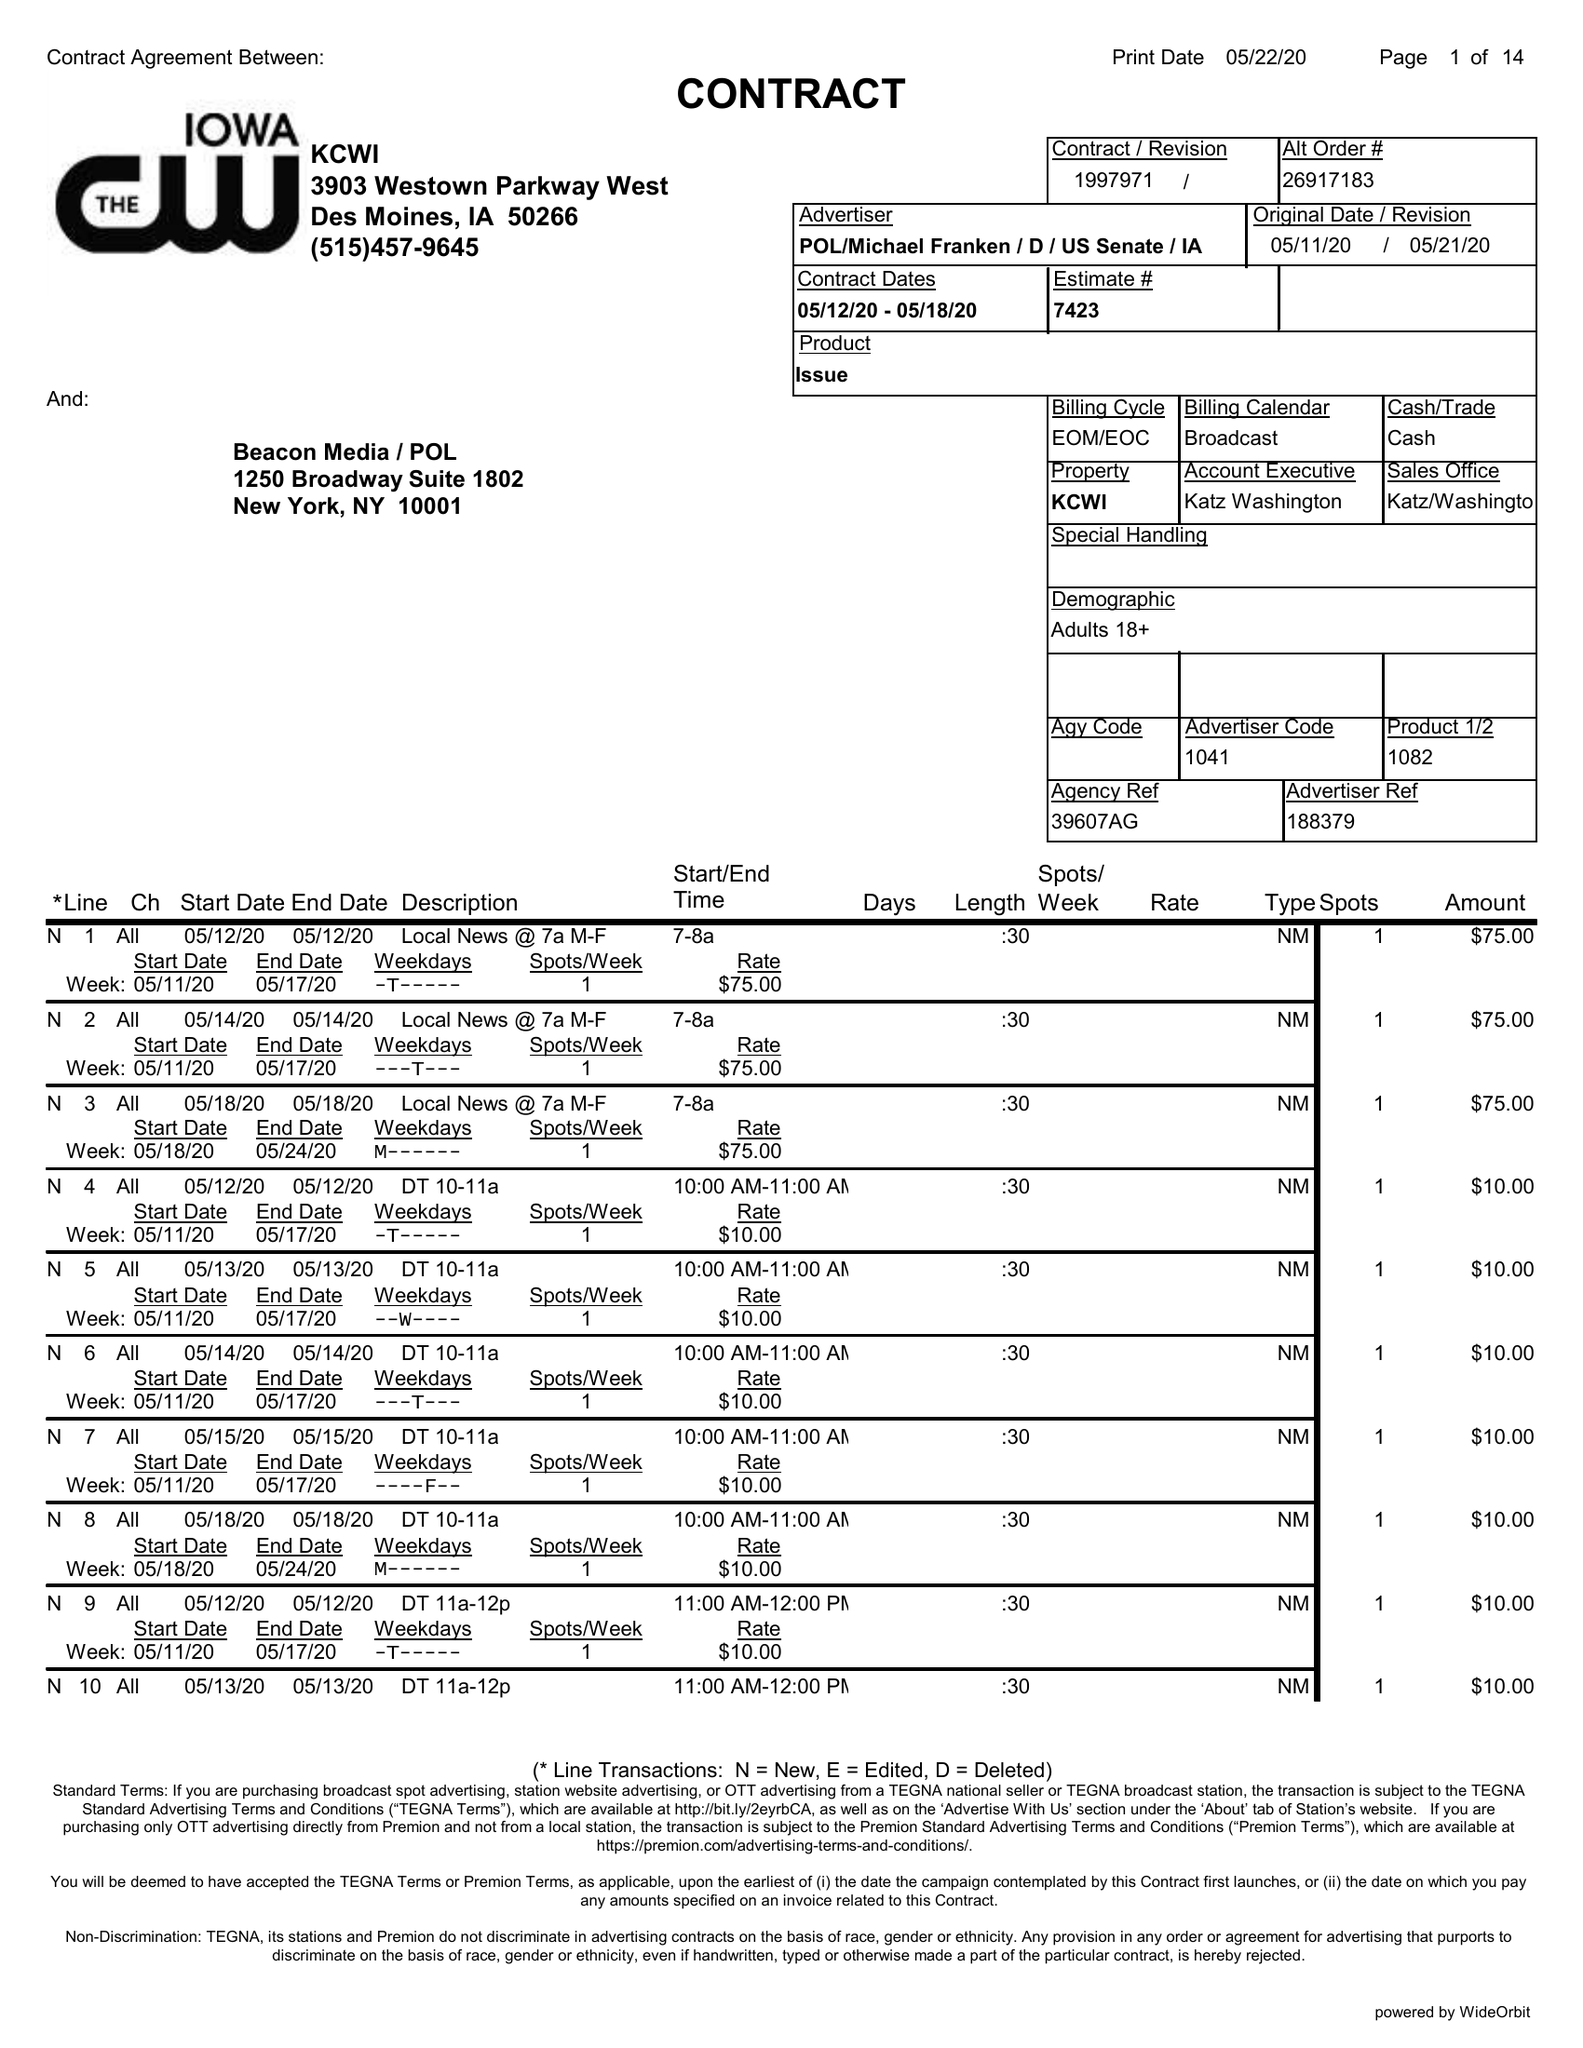What is the value for the contract_num?
Answer the question using a single word or phrase. 1997971 